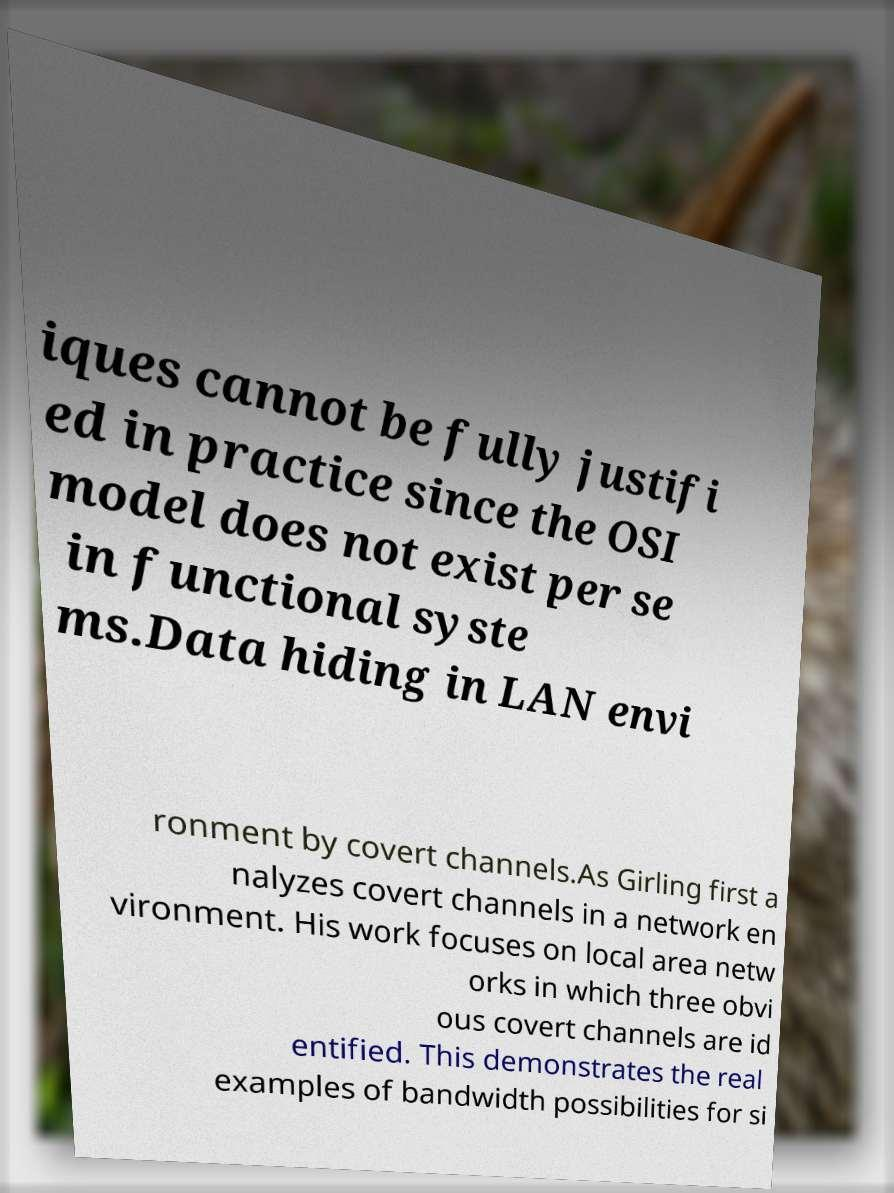Could you assist in decoding the text presented in this image and type it out clearly? iques cannot be fully justifi ed in practice since the OSI model does not exist per se in functional syste ms.Data hiding in LAN envi ronment by covert channels.As Girling first a nalyzes covert channels in a network en vironment. His work focuses on local area netw orks in which three obvi ous covert channels are id entified. This demonstrates the real examples of bandwidth possibilities for si 